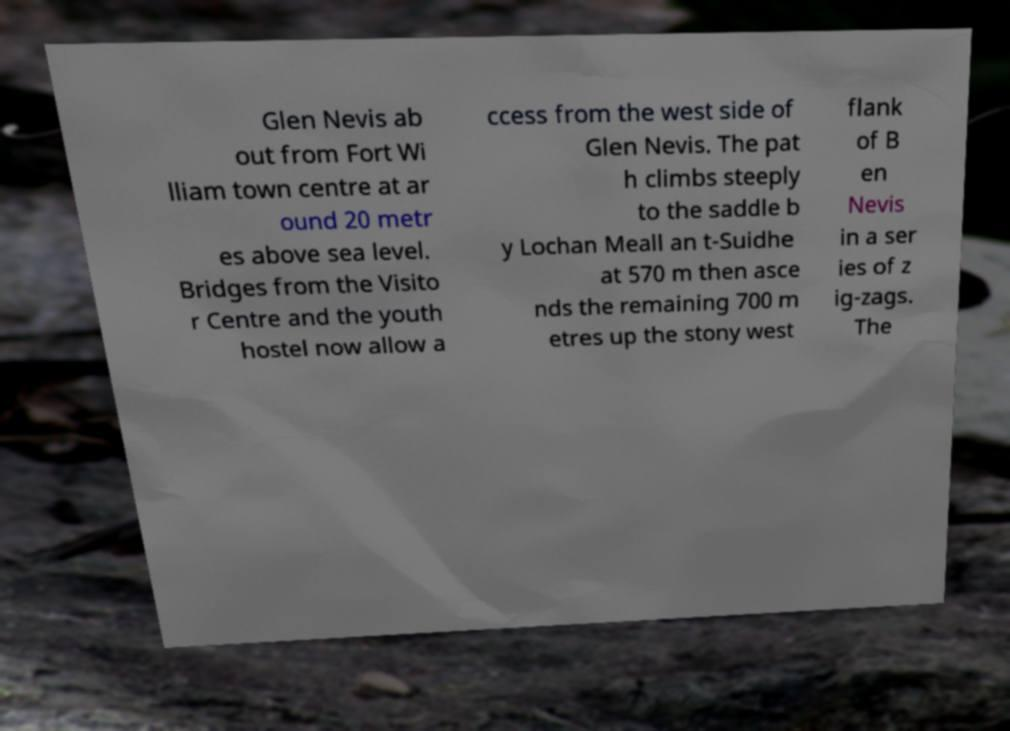For documentation purposes, I need the text within this image transcribed. Could you provide that? Glen Nevis ab out from Fort Wi lliam town centre at ar ound 20 metr es above sea level. Bridges from the Visito r Centre and the youth hostel now allow a ccess from the west side of Glen Nevis. The pat h climbs steeply to the saddle b y Lochan Meall an t-Suidhe at 570 m then asce nds the remaining 700 m etres up the stony west flank of B en Nevis in a ser ies of z ig-zags. The 